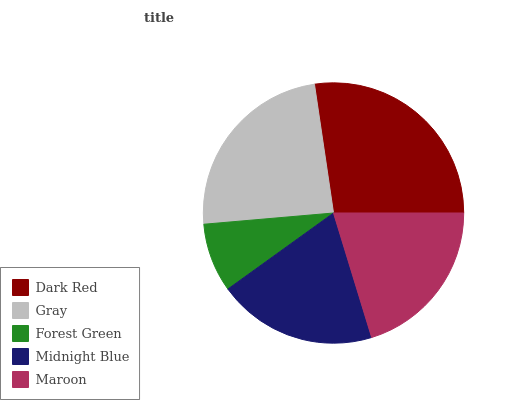Is Forest Green the minimum?
Answer yes or no. Yes. Is Dark Red the maximum?
Answer yes or no. Yes. Is Gray the minimum?
Answer yes or no. No. Is Gray the maximum?
Answer yes or no. No. Is Dark Red greater than Gray?
Answer yes or no. Yes. Is Gray less than Dark Red?
Answer yes or no. Yes. Is Gray greater than Dark Red?
Answer yes or no. No. Is Dark Red less than Gray?
Answer yes or no. No. Is Maroon the high median?
Answer yes or no. Yes. Is Maroon the low median?
Answer yes or no. Yes. Is Dark Red the high median?
Answer yes or no. No. Is Gray the low median?
Answer yes or no. No. 